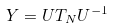<formula> <loc_0><loc_0><loc_500><loc_500>Y = U T _ { N } U ^ { - 1 }</formula> 